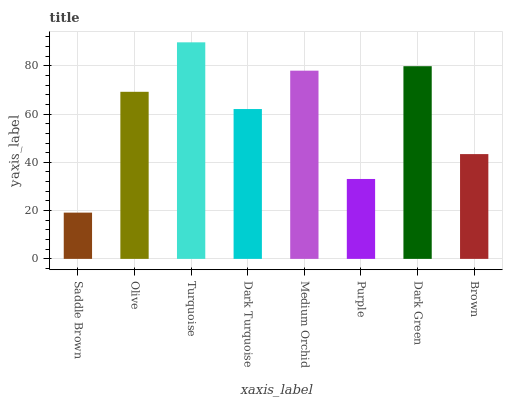Is Saddle Brown the minimum?
Answer yes or no. Yes. Is Turquoise the maximum?
Answer yes or no. Yes. Is Olive the minimum?
Answer yes or no. No. Is Olive the maximum?
Answer yes or no. No. Is Olive greater than Saddle Brown?
Answer yes or no. Yes. Is Saddle Brown less than Olive?
Answer yes or no. Yes. Is Saddle Brown greater than Olive?
Answer yes or no. No. Is Olive less than Saddle Brown?
Answer yes or no. No. Is Olive the high median?
Answer yes or no. Yes. Is Dark Turquoise the low median?
Answer yes or no. Yes. Is Purple the high median?
Answer yes or no. No. Is Brown the low median?
Answer yes or no. No. 